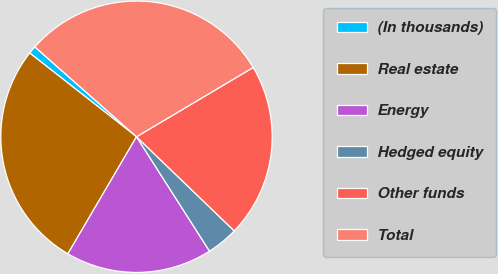Convert chart to OTSL. <chart><loc_0><loc_0><loc_500><loc_500><pie_chart><fcel>(In thousands)<fcel>Real estate<fcel>Energy<fcel>Hedged equity<fcel>Other funds<fcel>Total<nl><fcel>0.94%<fcel>27.14%<fcel>17.48%<fcel>3.76%<fcel>20.73%<fcel>29.95%<nl></chart> 